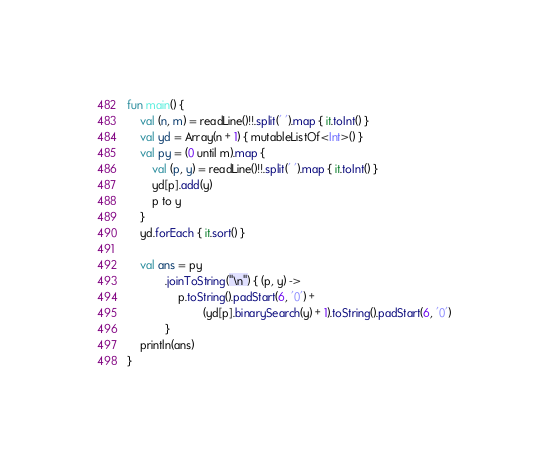<code> <loc_0><loc_0><loc_500><loc_500><_Kotlin_>fun main() {
    val (n, m) = readLine()!!.split(' ').map { it.toInt() }
    val yd = Array(n + 1) { mutableListOf<Int>() }
    val py = (0 until m).map {
        val (p, y) = readLine()!!.split(' ').map { it.toInt() }
        yd[p].add(y)
        p to y
    }
    yd.forEach { it.sort() }

    val ans = py
            .joinToString("\n") { (p, y) ->
                p.toString().padStart(6, '0') +
                        (yd[p].binarySearch(y) + 1).toString().padStart(6, '0')
            }
    println(ans)
}
</code> 